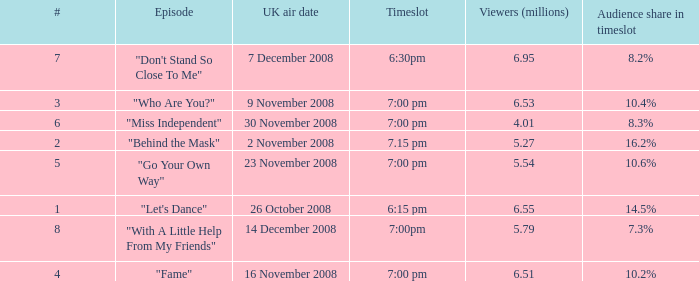Name the total number of timeslot for number 1 1.0. 